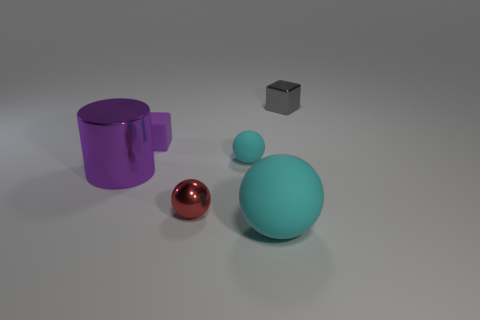There is a cube in front of the metal object that is behind the big cylinder; are there any large cyan balls behind it?
Offer a very short reply. No. Is there anything else that is the same size as the gray metallic object?
Your response must be concise. Yes. What color is the cube that is made of the same material as the tiny red object?
Keep it short and to the point. Gray. There is a metallic thing that is to the right of the tiny matte block and to the left of the gray block; what is its size?
Offer a very short reply. Small. Is the number of large cylinders that are in front of the tiny red ball less than the number of small metal spheres on the left side of the purple shiny cylinder?
Keep it short and to the point. No. Are the tiny sphere on the right side of the red metallic thing and the tiny sphere that is in front of the purple metal cylinder made of the same material?
Your answer should be compact. No. There is a ball that is the same color as the big rubber object; what material is it?
Provide a succinct answer. Rubber. There is a metal thing that is both in front of the purple matte cube and on the right side of the purple cube; what is its shape?
Provide a succinct answer. Sphere. What material is the large thing on the right side of the purple thing to the right of the large purple object?
Make the answer very short. Rubber. Are there more rubber spheres than small purple blocks?
Ensure brevity in your answer.  Yes. 